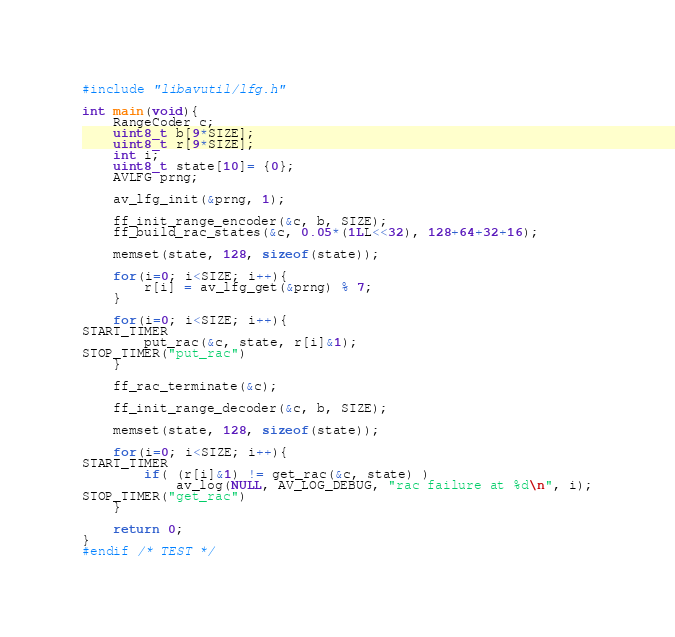Convert code to text. <code><loc_0><loc_0><loc_500><loc_500><_C_>#include "libavutil/lfg.h"

int main(void){
    RangeCoder c;
    uint8_t b[9*SIZE];
    uint8_t r[9*SIZE];
    int i;
    uint8_t state[10]= {0};
    AVLFG prng;

    av_lfg_init(&prng, 1);

    ff_init_range_encoder(&c, b, SIZE);
    ff_build_rac_states(&c, 0.05*(1LL<<32), 128+64+32+16);

    memset(state, 128, sizeof(state));

    for(i=0; i<SIZE; i++){
        r[i] = av_lfg_get(&prng) % 7;
    }

    for(i=0; i<SIZE; i++){
START_TIMER
        put_rac(&c, state, r[i]&1);
STOP_TIMER("put_rac")
    }

    ff_rac_terminate(&c);

    ff_init_range_decoder(&c, b, SIZE);

    memset(state, 128, sizeof(state));

    for(i=0; i<SIZE; i++){
START_TIMER
        if( (r[i]&1) != get_rac(&c, state) )
            av_log(NULL, AV_LOG_DEBUG, "rac failure at %d\n", i);
STOP_TIMER("get_rac")
    }

    return 0;
}
#endif /* TEST */
</code> 